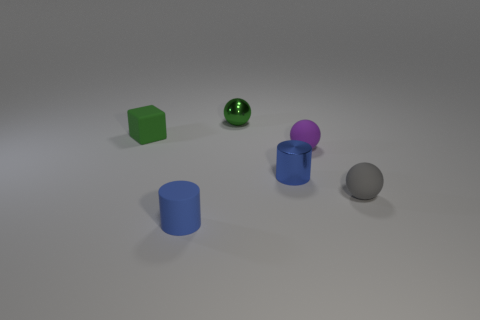What could be the purpose of this arrangement of objects? This arrangement could serve several purposes. It might be a minimalist artistic composition, designed to focus on shape, color, and form. Alternatively, it could be a setup for a study in photography or lighting, using objects of different materials and colors to see how they interact with light. It may also simply be an arbitrary grouping of objects, to no particular end beyond the aesthetic or the experimental. 